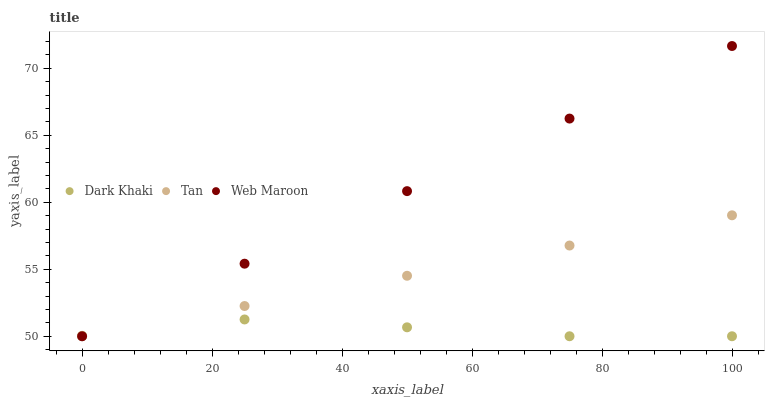Does Dark Khaki have the minimum area under the curve?
Answer yes or no. Yes. Does Web Maroon have the maximum area under the curve?
Answer yes or no. Yes. Does Tan have the minimum area under the curve?
Answer yes or no. No. Does Tan have the maximum area under the curve?
Answer yes or no. No. Is Tan the smoothest?
Answer yes or no. Yes. Is Dark Khaki the roughest?
Answer yes or no. Yes. Is Web Maroon the smoothest?
Answer yes or no. No. Is Web Maroon the roughest?
Answer yes or no. No. Does Dark Khaki have the lowest value?
Answer yes or no. Yes. Does Web Maroon have the highest value?
Answer yes or no. Yes. Does Tan have the highest value?
Answer yes or no. No. Does Tan intersect Dark Khaki?
Answer yes or no. Yes. Is Tan less than Dark Khaki?
Answer yes or no. No. Is Tan greater than Dark Khaki?
Answer yes or no. No. 